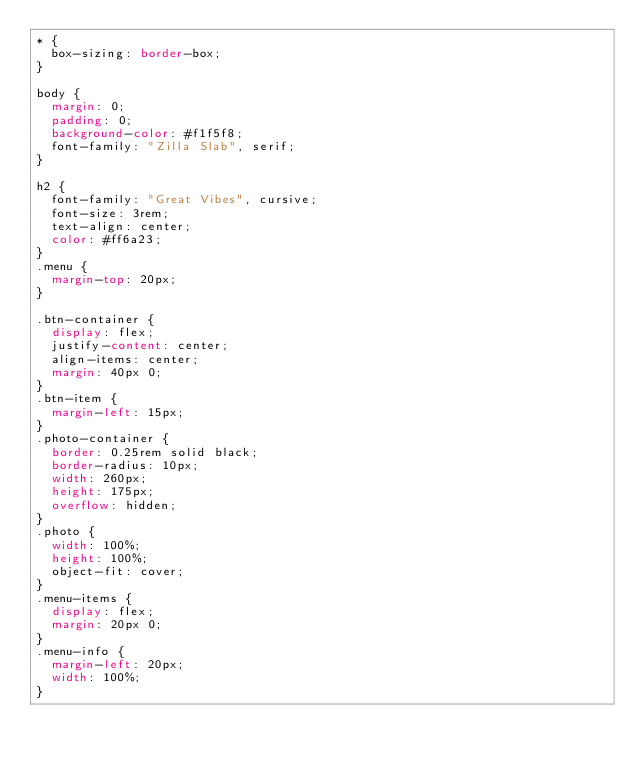Convert code to text. <code><loc_0><loc_0><loc_500><loc_500><_CSS_>* {
  box-sizing: border-box;
}

body {
  margin: 0;
  padding: 0;
  background-color: #f1f5f8;
  font-family: "Zilla Slab", serif;
}

h2 {
  font-family: "Great Vibes", cursive;
  font-size: 3rem;
  text-align: center;
  color: #ff6a23;
}
.menu {
  margin-top: 20px;
}

.btn-container {
  display: flex;
  justify-content: center;
  align-items: center;
  margin: 40px 0;
}
.btn-item {
  margin-left: 15px;
}
.photo-container {
  border: 0.25rem solid black;
  border-radius: 10px;
  width: 260px;
  height: 175px;
  overflow: hidden;
}
.photo {
  width: 100%;
  height: 100%;
  object-fit: cover;
}
.menu-items {
  display: flex;
  margin: 20px 0;
}
.menu-info {
  margin-left: 20px;
  width: 100%;
}</code> 